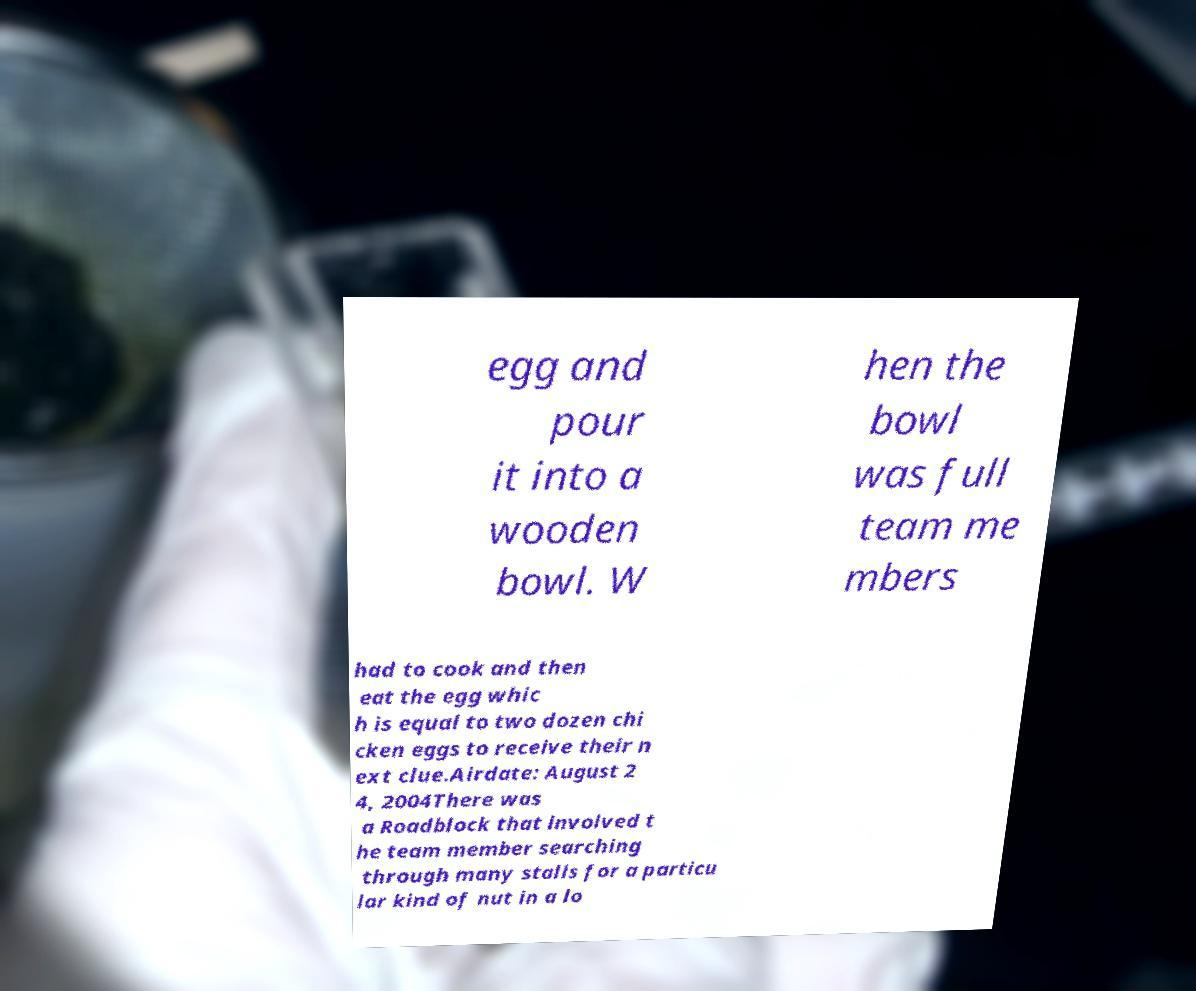Can you read and provide the text displayed in the image?This photo seems to have some interesting text. Can you extract and type it out for me? egg and pour it into a wooden bowl. W hen the bowl was full team me mbers had to cook and then eat the egg whic h is equal to two dozen chi cken eggs to receive their n ext clue.Airdate: August 2 4, 2004There was a Roadblock that involved t he team member searching through many stalls for a particu lar kind of nut in a lo 